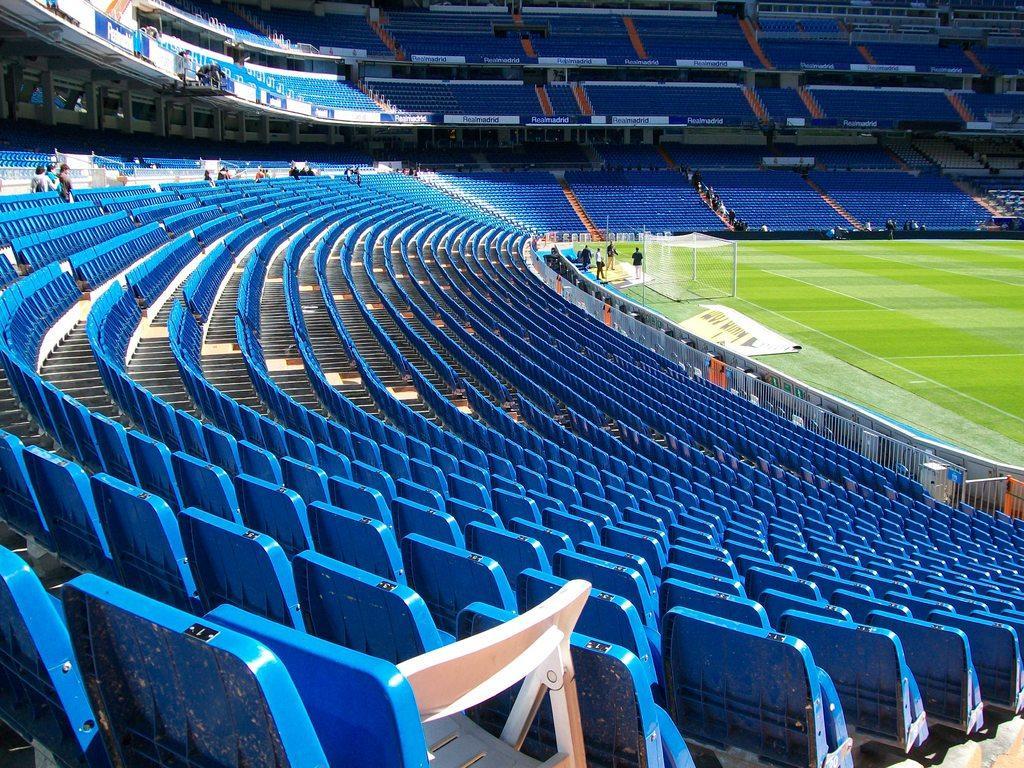Describe this image in one or two sentences. In this image I can see a stadium , on the stadium I can see green color ground and there are some persons visible on the ground and I can see there are so many blue color chairs visible in front of the ground. on chairs I can see persons. 